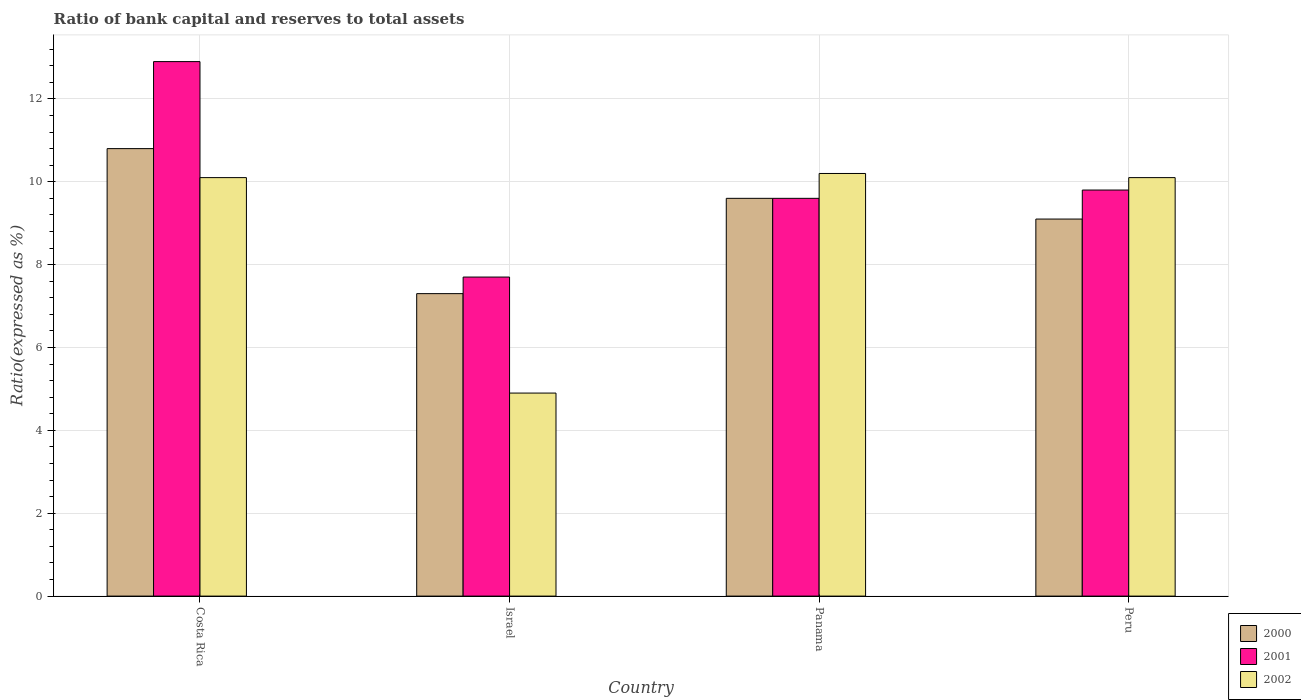How many different coloured bars are there?
Provide a short and direct response. 3. How many bars are there on the 1st tick from the right?
Your answer should be very brief. 3. What is the label of the 1st group of bars from the left?
Give a very brief answer. Costa Rica. What is the ratio of bank capital and reserves to total assets in 2000 in Costa Rica?
Ensure brevity in your answer.  10.8. Across all countries, what is the minimum ratio of bank capital and reserves to total assets in 2001?
Offer a very short reply. 7.7. In which country was the ratio of bank capital and reserves to total assets in 2002 maximum?
Give a very brief answer. Panama. In which country was the ratio of bank capital and reserves to total assets in 2001 minimum?
Offer a terse response. Israel. What is the total ratio of bank capital and reserves to total assets in 2002 in the graph?
Make the answer very short. 35.3. What is the difference between the ratio of bank capital and reserves to total assets in 2002 in Israel and that in Peru?
Give a very brief answer. -5.2. What is the difference between the ratio of bank capital and reserves to total assets in 2000 in Israel and the ratio of bank capital and reserves to total assets in 2002 in Costa Rica?
Ensure brevity in your answer.  -2.8. What is the average ratio of bank capital and reserves to total assets in 2000 per country?
Your response must be concise. 9.2. What is the difference between the ratio of bank capital and reserves to total assets of/in 2002 and ratio of bank capital and reserves to total assets of/in 2000 in Israel?
Make the answer very short. -2.4. What is the ratio of the ratio of bank capital and reserves to total assets in 2000 in Panama to that in Peru?
Keep it short and to the point. 1.05. Is the ratio of bank capital and reserves to total assets in 2002 in Panama less than that in Peru?
Ensure brevity in your answer.  No. Is the difference between the ratio of bank capital and reserves to total assets in 2002 in Costa Rica and Israel greater than the difference between the ratio of bank capital and reserves to total assets in 2000 in Costa Rica and Israel?
Keep it short and to the point. Yes. What is the difference between the highest and the second highest ratio of bank capital and reserves to total assets in 2001?
Your answer should be very brief. -3.1. What is the difference between the highest and the lowest ratio of bank capital and reserves to total assets in 2000?
Ensure brevity in your answer.  3.5. In how many countries, is the ratio of bank capital and reserves to total assets in 2001 greater than the average ratio of bank capital and reserves to total assets in 2001 taken over all countries?
Ensure brevity in your answer.  1. Is the sum of the ratio of bank capital and reserves to total assets in 2002 in Panama and Peru greater than the maximum ratio of bank capital and reserves to total assets in 2000 across all countries?
Make the answer very short. Yes. Is it the case that in every country, the sum of the ratio of bank capital and reserves to total assets in 2002 and ratio of bank capital and reserves to total assets in 2001 is greater than the ratio of bank capital and reserves to total assets in 2000?
Ensure brevity in your answer.  Yes. How many bars are there?
Ensure brevity in your answer.  12. How many countries are there in the graph?
Ensure brevity in your answer.  4. Are the values on the major ticks of Y-axis written in scientific E-notation?
Make the answer very short. No. Does the graph contain any zero values?
Keep it short and to the point. No. How many legend labels are there?
Give a very brief answer. 3. What is the title of the graph?
Make the answer very short. Ratio of bank capital and reserves to total assets. Does "1982" appear as one of the legend labels in the graph?
Give a very brief answer. No. What is the label or title of the X-axis?
Give a very brief answer. Country. What is the label or title of the Y-axis?
Offer a terse response. Ratio(expressed as %). What is the Ratio(expressed as %) in 2000 in Costa Rica?
Offer a very short reply. 10.8. What is the Ratio(expressed as %) in 2001 in Costa Rica?
Your answer should be compact. 12.9. What is the Ratio(expressed as %) in 2002 in Costa Rica?
Provide a short and direct response. 10.1. What is the Ratio(expressed as %) in 2002 in Israel?
Give a very brief answer. 4.9. What is the Ratio(expressed as %) of 2000 in Panama?
Ensure brevity in your answer.  9.6. What is the Ratio(expressed as %) of 2000 in Peru?
Your response must be concise. 9.1. What is the Ratio(expressed as %) in 2001 in Peru?
Your response must be concise. 9.8. What is the Ratio(expressed as %) of 2002 in Peru?
Your answer should be very brief. 10.1. Across all countries, what is the minimum Ratio(expressed as %) in 2000?
Your answer should be compact. 7.3. Across all countries, what is the minimum Ratio(expressed as %) of 2001?
Provide a succinct answer. 7.7. What is the total Ratio(expressed as %) in 2000 in the graph?
Your response must be concise. 36.8. What is the total Ratio(expressed as %) in 2002 in the graph?
Your answer should be compact. 35.3. What is the difference between the Ratio(expressed as %) in 2000 in Costa Rica and that in Panama?
Offer a terse response. 1.2. What is the difference between the Ratio(expressed as %) of 2001 in Costa Rica and that in Panama?
Provide a short and direct response. 3.3. What is the difference between the Ratio(expressed as %) of 2000 in Costa Rica and that in Peru?
Ensure brevity in your answer.  1.7. What is the difference between the Ratio(expressed as %) of 2000 in Israel and that in Panama?
Make the answer very short. -2.3. What is the difference between the Ratio(expressed as %) in 2000 in Israel and that in Peru?
Your answer should be very brief. -1.8. What is the difference between the Ratio(expressed as %) of 2000 in Panama and that in Peru?
Your response must be concise. 0.5. What is the difference between the Ratio(expressed as %) in 2001 in Costa Rica and the Ratio(expressed as %) in 2002 in Israel?
Offer a terse response. 8. What is the difference between the Ratio(expressed as %) in 2000 in Costa Rica and the Ratio(expressed as %) in 2001 in Panama?
Your answer should be compact. 1.2. What is the difference between the Ratio(expressed as %) of 2000 in Costa Rica and the Ratio(expressed as %) of 2002 in Panama?
Your response must be concise. 0.6. What is the difference between the Ratio(expressed as %) of 2001 in Costa Rica and the Ratio(expressed as %) of 2002 in Panama?
Provide a succinct answer. 2.7. What is the difference between the Ratio(expressed as %) in 2000 in Costa Rica and the Ratio(expressed as %) in 2002 in Peru?
Offer a terse response. 0.7. What is the difference between the Ratio(expressed as %) in 2000 in Israel and the Ratio(expressed as %) in 2001 in Panama?
Your answer should be compact. -2.3. What is the difference between the Ratio(expressed as %) in 2001 in Israel and the Ratio(expressed as %) in 2002 in Panama?
Give a very brief answer. -2.5. What is the difference between the Ratio(expressed as %) of 2000 in Israel and the Ratio(expressed as %) of 2002 in Peru?
Your answer should be compact. -2.8. What is the difference between the Ratio(expressed as %) of 2001 in Panama and the Ratio(expressed as %) of 2002 in Peru?
Provide a short and direct response. -0.5. What is the average Ratio(expressed as %) of 2000 per country?
Your answer should be compact. 9.2. What is the average Ratio(expressed as %) in 2002 per country?
Ensure brevity in your answer.  8.82. What is the difference between the Ratio(expressed as %) in 2000 and Ratio(expressed as %) in 2001 in Costa Rica?
Your answer should be compact. -2.1. What is the difference between the Ratio(expressed as %) of 2000 and Ratio(expressed as %) of 2001 in Israel?
Your response must be concise. -0.4. What is the difference between the Ratio(expressed as %) in 2001 and Ratio(expressed as %) in 2002 in Israel?
Ensure brevity in your answer.  2.8. What is the difference between the Ratio(expressed as %) in 2000 and Ratio(expressed as %) in 2002 in Panama?
Your response must be concise. -0.6. What is the difference between the Ratio(expressed as %) in 2001 and Ratio(expressed as %) in 2002 in Panama?
Keep it short and to the point. -0.6. What is the difference between the Ratio(expressed as %) of 2000 and Ratio(expressed as %) of 2001 in Peru?
Offer a very short reply. -0.7. What is the difference between the Ratio(expressed as %) of 2000 and Ratio(expressed as %) of 2002 in Peru?
Offer a terse response. -1. What is the ratio of the Ratio(expressed as %) in 2000 in Costa Rica to that in Israel?
Offer a terse response. 1.48. What is the ratio of the Ratio(expressed as %) in 2001 in Costa Rica to that in Israel?
Provide a short and direct response. 1.68. What is the ratio of the Ratio(expressed as %) of 2002 in Costa Rica to that in Israel?
Keep it short and to the point. 2.06. What is the ratio of the Ratio(expressed as %) of 2001 in Costa Rica to that in Panama?
Your answer should be very brief. 1.34. What is the ratio of the Ratio(expressed as %) of 2002 in Costa Rica to that in Panama?
Give a very brief answer. 0.99. What is the ratio of the Ratio(expressed as %) of 2000 in Costa Rica to that in Peru?
Give a very brief answer. 1.19. What is the ratio of the Ratio(expressed as %) in 2001 in Costa Rica to that in Peru?
Keep it short and to the point. 1.32. What is the ratio of the Ratio(expressed as %) in 2000 in Israel to that in Panama?
Ensure brevity in your answer.  0.76. What is the ratio of the Ratio(expressed as %) of 2001 in Israel to that in Panama?
Give a very brief answer. 0.8. What is the ratio of the Ratio(expressed as %) of 2002 in Israel to that in Panama?
Offer a very short reply. 0.48. What is the ratio of the Ratio(expressed as %) of 2000 in Israel to that in Peru?
Give a very brief answer. 0.8. What is the ratio of the Ratio(expressed as %) of 2001 in Israel to that in Peru?
Offer a terse response. 0.79. What is the ratio of the Ratio(expressed as %) of 2002 in Israel to that in Peru?
Provide a short and direct response. 0.49. What is the ratio of the Ratio(expressed as %) of 2000 in Panama to that in Peru?
Offer a terse response. 1.05. What is the ratio of the Ratio(expressed as %) in 2001 in Panama to that in Peru?
Give a very brief answer. 0.98. What is the ratio of the Ratio(expressed as %) of 2002 in Panama to that in Peru?
Offer a very short reply. 1.01. What is the difference between the highest and the second highest Ratio(expressed as %) in 2000?
Give a very brief answer. 1.2. What is the difference between the highest and the second highest Ratio(expressed as %) in 2001?
Offer a very short reply. 3.1. What is the difference between the highest and the lowest Ratio(expressed as %) in 2000?
Your answer should be very brief. 3.5. What is the difference between the highest and the lowest Ratio(expressed as %) of 2002?
Make the answer very short. 5.3. 